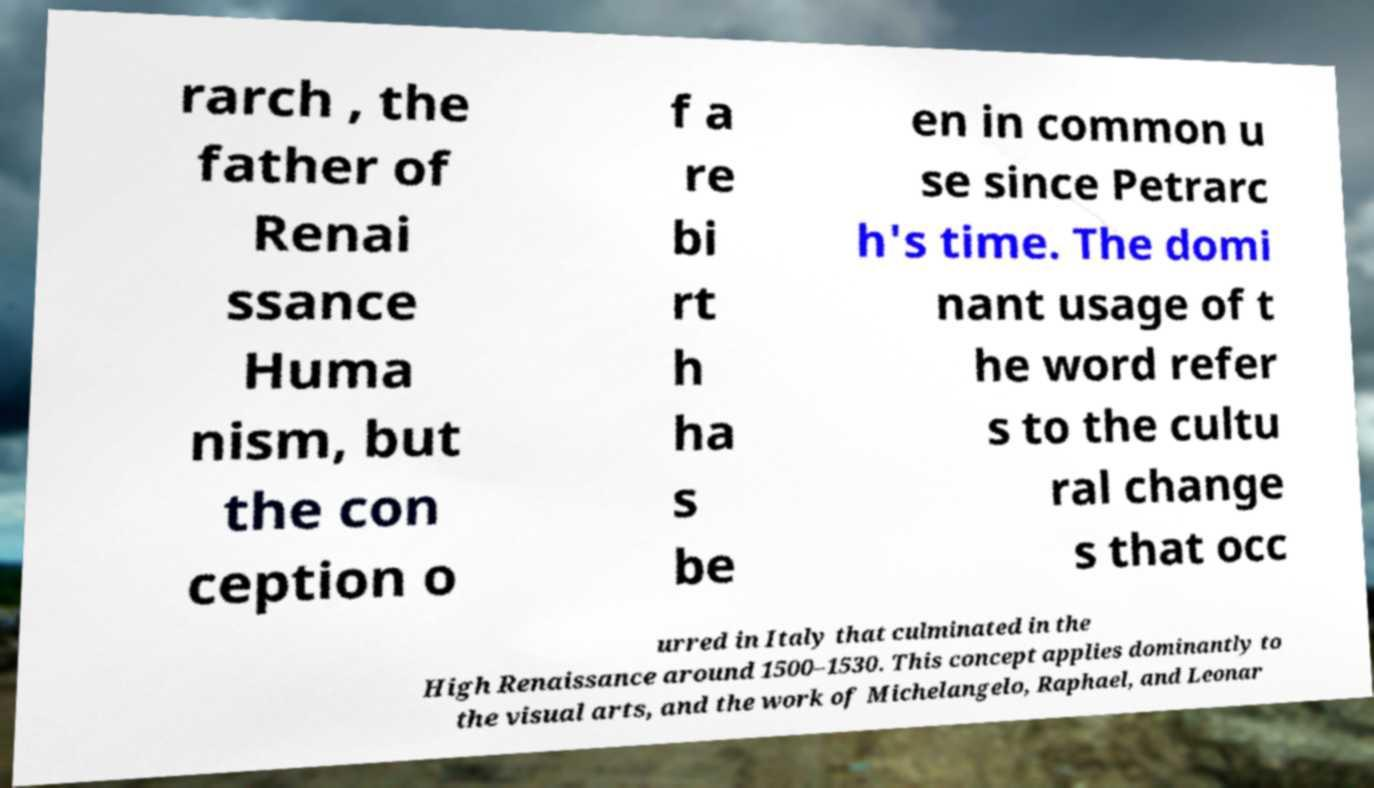Can you read and provide the text displayed in the image?This photo seems to have some interesting text. Can you extract and type it out for me? rarch , the father of Renai ssance Huma nism, but the con ception o f a re bi rt h ha s be en in common u se since Petrarc h's time. The domi nant usage of t he word refer s to the cultu ral change s that occ urred in Italy that culminated in the High Renaissance around 1500–1530. This concept applies dominantly to the visual arts, and the work of Michelangelo, Raphael, and Leonar 